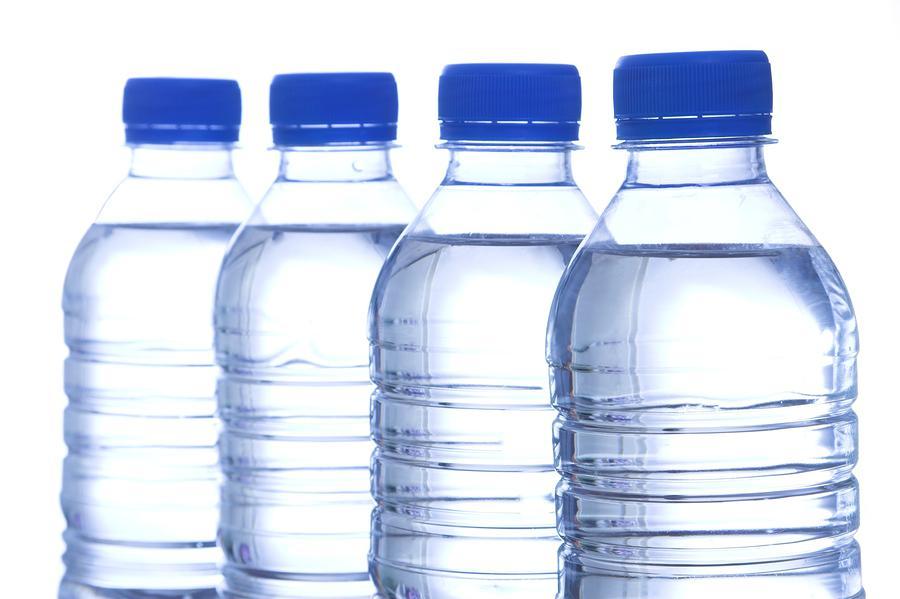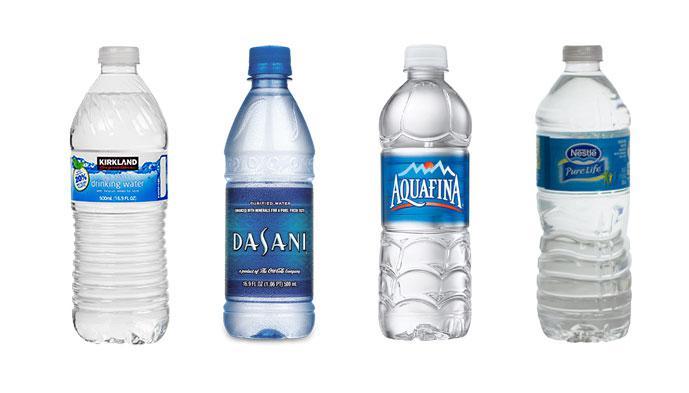The first image is the image on the left, the second image is the image on the right. Considering the images on both sides, is "A clear blue water bottle has a black top with loop." valid? Answer yes or no. No. The first image is the image on the left, the second image is the image on the right. Given the left and right images, does the statement "An image shows one sport-type water bottle with a loop on the lid." hold true? Answer yes or no. No. The first image is the image on the left, the second image is the image on the right. For the images displayed, is the sentence "There is exactly one water bottle in the image on the left." factually correct? Answer yes or no. No. 